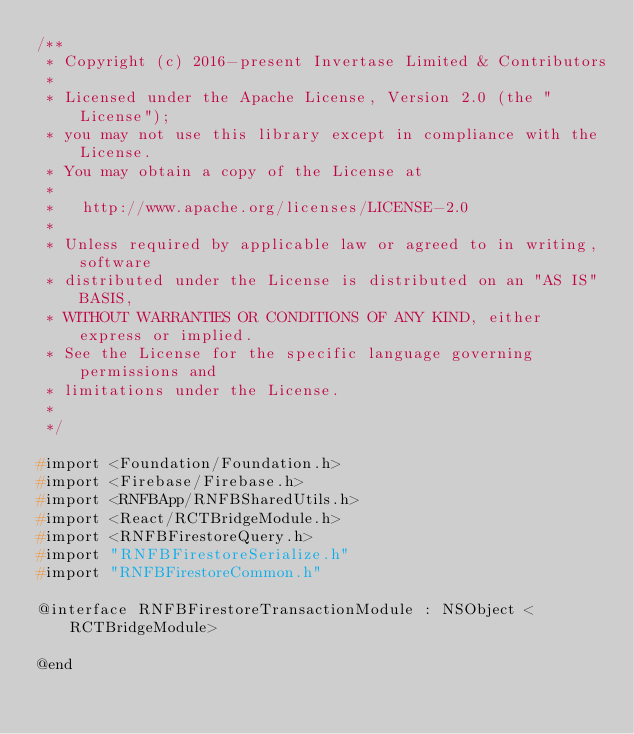<code> <loc_0><loc_0><loc_500><loc_500><_C_>/**
 * Copyright (c) 2016-present Invertase Limited & Contributors
 *
 * Licensed under the Apache License, Version 2.0 (the "License");
 * you may not use this library except in compliance with the License.
 * You may obtain a copy of the License at
 *
 *   http://www.apache.org/licenses/LICENSE-2.0
 *
 * Unless required by applicable law or agreed to in writing, software
 * distributed under the License is distributed on an "AS IS" BASIS,
 * WITHOUT WARRANTIES OR CONDITIONS OF ANY KIND, either express or implied.
 * See the License for the specific language governing permissions and
 * limitations under the License.
 *
 */

#import <Foundation/Foundation.h>
#import <Firebase/Firebase.h>
#import <RNFBApp/RNFBSharedUtils.h>
#import <React/RCTBridgeModule.h>
#import <RNFBFirestoreQuery.h>
#import "RNFBFirestoreSerialize.h"
#import "RNFBFirestoreCommon.h"

@interface RNFBFirestoreTransactionModule : NSObject <RCTBridgeModule>

@end
</code> 